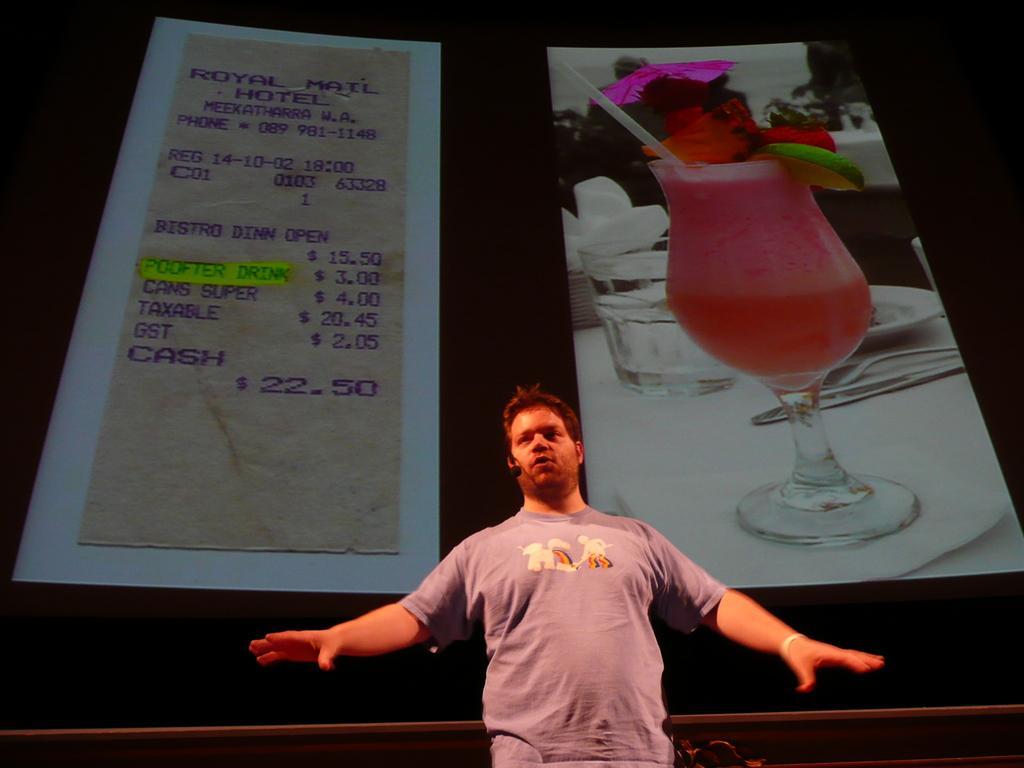In one or two sentences, can you explain what this image depicts? This image consists of a man. He has mic. He is speaking something. There are two pictures in the middle. One is of bill, other one is of glass. 